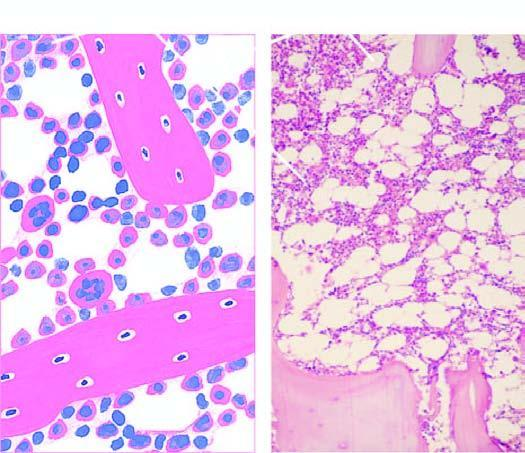what does approximately 50 % of the soft tissue of the bone consist of?
Answer the question using a single word or phrase. Haematopoietic tissue 